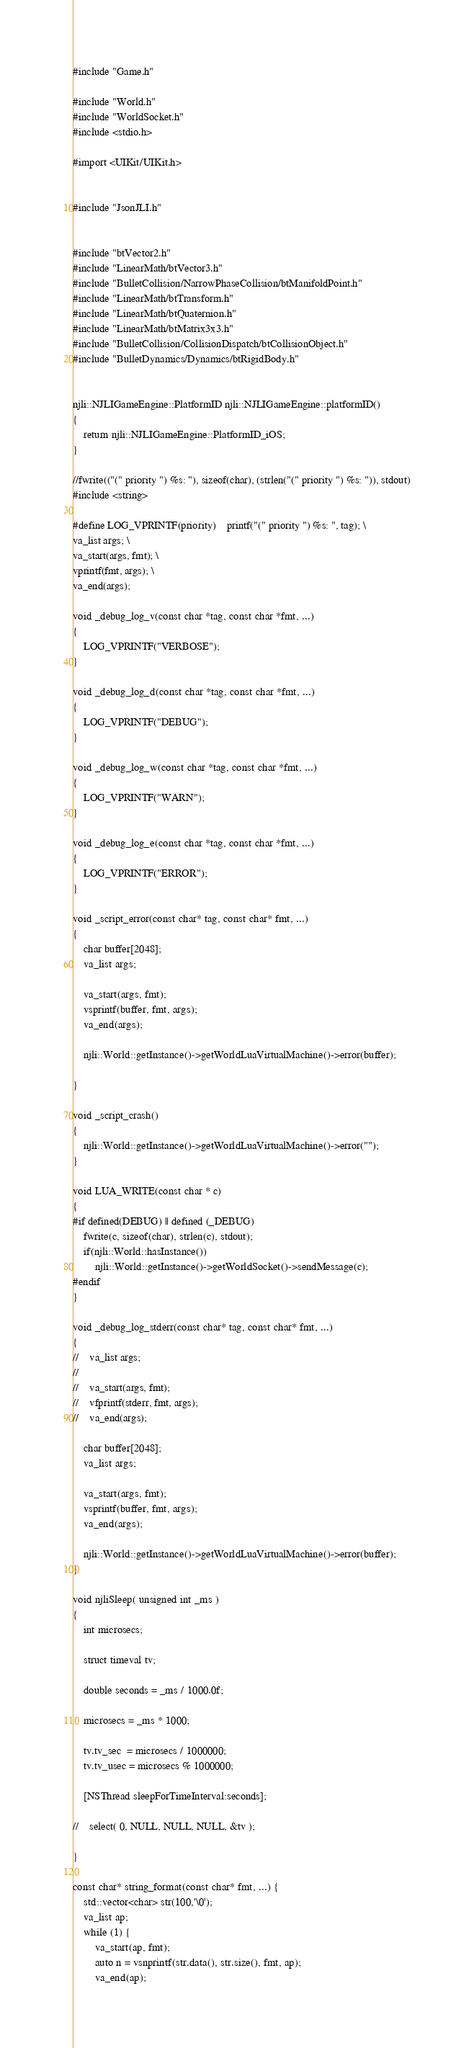<code> <loc_0><loc_0><loc_500><loc_500><_ObjectiveC_>#include "Game.h"

#include "World.h"
#include "WorldSocket.h"
#include <stdio.h>

#import <UIKit/UIKit.h>


#include "JsonJLI.h"


#include "btVector2.h"
#include "LinearMath/btVector3.h"
#include "BulletCollision/NarrowPhaseCollision/btManifoldPoint.h"
#include "LinearMath/btTransform.h"
#include "LinearMath/btQuaternion.h"
#include "LinearMath/btMatrix3x3.h"
#include "BulletCollision/CollisionDispatch/btCollisionObject.h"
#include "BulletDynamics/Dynamics/btRigidBody.h"


njli::NJLIGameEngine::PlatformID njli::NJLIGameEngine::platformID()
{
    return njli::NJLIGameEngine::PlatformID_iOS;
}

//fwrite(("(" priority ") %s: "), sizeof(char), (strlen("(" priority ") %s: ")), stdout)
#include <string>

#define LOG_VPRINTF(priority)	printf("(" priority ") %s: ", tag); \
va_list args; \
va_start(args, fmt); \
vprintf(fmt, args); \
va_end(args);

void _debug_log_v(const char *tag, const char *fmt, ...)
{
    LOG_VPRINTF("VERBOSE");
}

void _debug_log_d(const char *tag, const char *fmt, ...)
{
    LOG_VPRINTF("DEBUG");
}

void _debug_log_w(const char *tag, const char *fmt, ...)
{
    LOG_VPRINTF("WARN");
}

void _debug_log_e(const char *tag, const char *fmt, ...)
{
    LOG_VPRINTF("ERROR");
}

void _script_error(const char* tag, const char* fmt, ...)
{
    char buffer[2048];
    va_list args;
    
    va_start(args, fmt);
    vsprintf(buffer, fmt, args);
    va_end(args);
    
    njli::World::getInstance()->getWorldLuaVirtualMachine()->error(buffer);
    
}

void _script_crash()
{
    njli::World::getInstance()->getWorldLuaVirtualMachine()->error("");
}

void LUA_WRITE(const char * c)
{
#if defined(DEBUG) || defined (_DEBUG)
    fwrite(c, sizeof(char), strlen(c), stdout);
    if(njli::World::hasInstance())
        njli::World::getInstance()->getWorldSocket()->sendMessage(c);
#endif
}

void _debug_log_stderr(const char* tag, const char* fmt, ...)
{
//    va_list args;
//    
//    va_start(args, fmt);
//    vfprintf(stderr, fmt, args);
//    va_end(args);
    
    char buffer[2048];
    va_list args;
    
    va_start(args, fmt);
    vsprintf(buffer, fmt, args);
    va_end(args);
    
    njli::World::getInstance()->getWorldLuaVirtualMachine()->error(buffer);
}

void njliSleep( unsigned int _ms )
{
    int microsecs;
    
    struct timeval tv;
    
    double seconds = _ms / 1000.0f;
    
    microsecs = _ms * 1000;
    
    tv.tv_sec  = microsecs / 1000000;
    tv.tv_usec = microsecs % 1000000;
    
    [NSThread sleepForTimeInterval:seconds];
    
//    select( 0, NULL, NULL, NULL, &tv );
    
}

const char* string_format(const char* fmt, ...) {
    std::vector<char> str(100,'\0');
    va_list ap;
    while (1) {
        va_start(ap, fmt);
        auto n = vsnprintf(str.data(), str.size(), fmt, ap);
        va_end(ap);</code> 